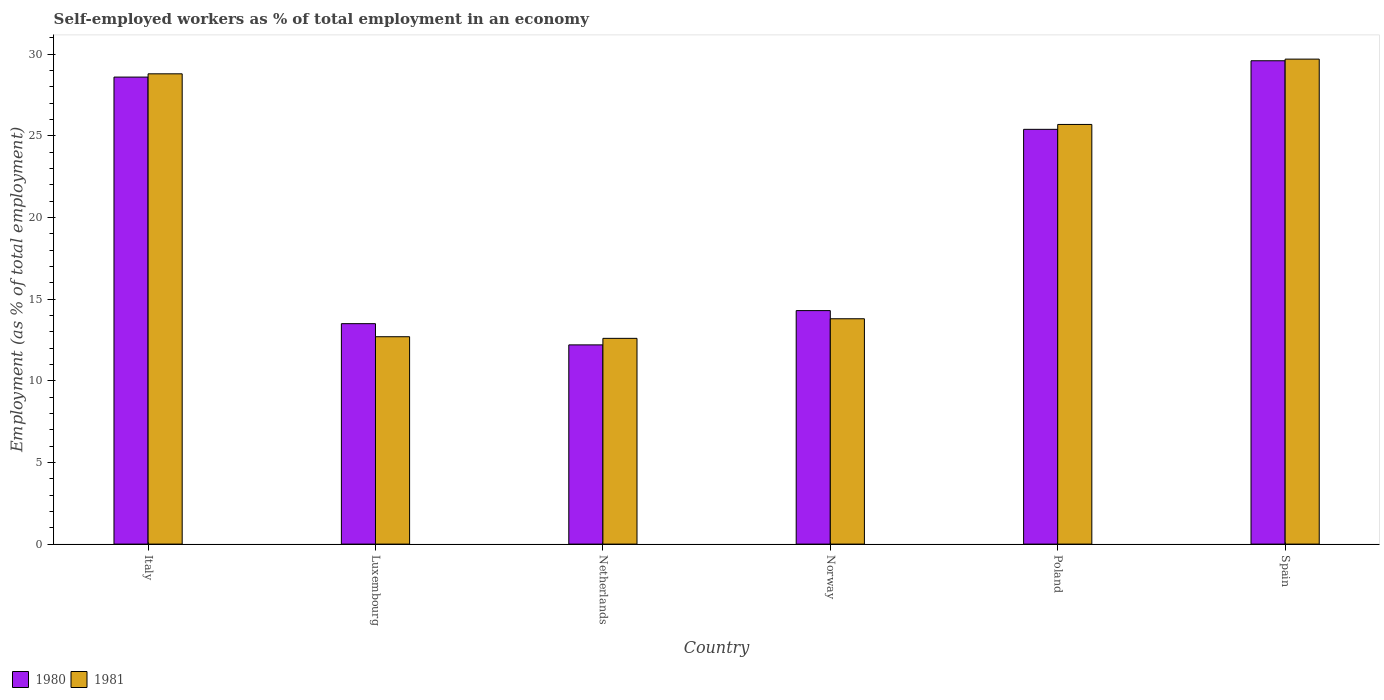How many different coloured bars are there?
Keep it short and to the point. 2. How many groups of bars are there?
Make the answer very short. 6. What is the label of the 6th group of bars from the left?
Provide a short and direct response. Spain. What is the percentage of self-employed workers in 1981 in Poland?
Keep it short and to the point. 25.7. Across all countries, what is the maximum percentage of self-employed workers in 1981?
Give a very brief answer. 29.7. Across all countries, what is the minimum percentage of self-employed workers in 1980?
Provide a succinct answer. 12.2. What is the total percentage of self-employed workers in 1981 in the graph?
Your response must be concise. 123.3. What is the difference between the percentage of self-employed workers in 1981 in Norway and that in Poland?
Provide a succinct answer. -11.9. What is the difference between the percentage of self-employed workers in 1981 in Poland and the percentage of self-employed workers in 1980 in Italy?
Give a very brief answer. -2.9. What is the average percentage of self-employed workers in 1980 per country?
Your answer should be compact. 20.6. What is the difference between the percentage of self-employed workers of/in 1980 and percentage of self-employed workers of/in 1981 in Poland?
Offer a very short reply. -0.3. What is the ratio of the percentage of self-employed workers in 1981 in Luxembourg to that in Netherlands?
Offer a very short reply. 1.01. Is the difference between the percentage of self-employed workers in 1980 in Netherlands and Norway greater than the difference between the percentage of self-employed workers in 1981 in Netherlands and Norway?
Your answer should be compact. No. What is the difference between the highest and the second highest percentage of self-employed workers in 1980?
Your answer should be very brief. -3.2. What is the difference between the highest and the lowest percentage of self-employed workers in 1980?
Give a very brief answer. 17.4. In how many countries, is the percentage of self-employed workers in 1980 greater than the average percentage of self-employed workers in 1980 taken over all countries?
Provide a short and direct response. 3. What does the 1st bar from the left in Luxembourg represents?
Provide a succinct answer. 1980. What does the 1st bar from the right in Luxembourg represents?
Provide a short and direct response. 1981. How many bars are there?
Offer a terse response. 12. How many countries are there in the graph?
Offer a terse response. 6. How many legend labels are there?
Give a very brief answer. 2. What is the title of the graph?
Offer a very short reply. Self-employed workers as % of total employment in an economy. Does "1971" appear as one of the legend labels in the graph?
Give a very brief answer. No. What is the label or title of the Y-axis?
Provide a short and direct response. Employment (as % of total employment). What is the Employment (as % of total employment) of 1980 in Italy?
Provide a succinct answer. 28.6. What is the Employment (as % of total employment) of 1981 in Italy?
Keep it short and to the point. 28.8. What is the Employment (as % of total employment) in 1981 in Luxembourg?
Offer a terse response. 12.7. What is the Employment (as % of total employment) of 1980 in Netherlands?
Ensure brevity in your answer.  12.2. What is the Employment (as % of total employment) in 1981 in Netherlands?
Give a very brief answer. 12.6. What is the Employment (as % of total employment) in 1980 in Norway?
Make the answer very short. 14.3. What is the Employment (as % of total employment) in 1981 in Norway?
Provide a succinct answer. 13.8. What is the Employment (as % of total employment) of 1980 in Poland?
Your answer should be very brief. 25.4. What is the Employment (as % of total employment) in 1981 in Poland?
Your answer should be very brief. 25.7. What is the Employment (as % of total employment) of 1980 in Spain?
Your answer should be compact. 29.6. What is the Employment (as % of total employment) of 1981 in Spain?
Keep it short and to the point. 29.7. Across all countries, what is the maximum Employment (as % of total employment) of 1980?
Your answer should be compact. 29.6. Across all countries, what is the maximum Employment (as % of total employment) in 1981?
Provide a succinct answer. 29.7. Across all countries, what is the minimum Employment (as % of total employment) in 1980?
Your answer should be very brief. 12.2. Across all countries, what is the minimum Employment (as % of total employment) in 1981?
Provide a short and direct response. 12.6. What is the total Employment (as % of total employment) of 1980 in the graph?
Ensure brevity in your answer.  123.6. What is the total Employment (as % of total employment) in 1981 in the graph?
Offer a very short reply. 123.3. What is the difference between the Employment (as % of total employment) in 1980 in Italy and that in Luxembourg?
Keep it short and to the point. 15.1. What is the difference between the Employment (as % of total employment) in 1981 in Italy and that in Luxembourg?
Provide a short and direct response. 16.1. What is the difference between the Employment (as % of total employment) in 1981 in Italy and that in Netherlands?
Offer a terse response. 16.2. What is the difference between the Employment (as % of total employment) in 1980 in Italy and that in Norway?
Give a very brief answer. 14.3. What is the difference between the Employment (as % of total employment) of 1981 in Italy and that in Norway?
Your answer should be very brief. 15. What is the difference between the Employment (as % of total employment) of 1980 in Italy and that in Poland?
Offer a terse response. 3.2. What is the difference between the Employment (as % of total employment) of 1981 in Italy and that in Spain?
Your answer should be compact. -0.9. What is the difference between the Employment (as % of total employment) of 1980 in Luxembourg and that in Netherlands?
Provide a short and direct response. 1.3. What is the difference between the Employment (as % of total employment) of 1981 in Luxembourg and that in Norway?
Give a very brief answer. -1.1. What is the difference between the Employment (as % of total employment) in 1981 in Luxembourg and that in Poland?
Give a very brief answer. -13. What is the difference between the Employment (as % of total employment) in 1980 in Luxembourg and that in Spain?
Keep it short and to the point. -16.1. What is the difference between the Employment (as % of total employment) in 1981 in Luxembourg and that in Spain?
Your response must be concise. -17. What is the difference between the Employment (as % of total employment) of 1980 in Netherlands and that in Norway?
Provide a short and direct response. -2.1. What is the difference between the Employment (as % of total employment) in 1980 in Netherlands and that in Poland?
Provide a succinct answer. -13.2. What is the difference between the Employment (as % of total employment) of 1980 in Netherlands and that in Spain?
Provide a succinct answer. -17.4. What is the difference between the Employment (as % of total employment) in 1981 in Netherlands and that in Spain?
Your response must be concise. -17.1. What is the difference between the Employment (as % of total employment) in 1980 in Norway and that in Spain?
Provide a succinct answer. -15.3. What is the difference between the Employment (as % of total employment) in 1981 in Norway and that in Spain?
Give a very brief answer. -15.9. What is the difference between the Employment (as % of total employment) of 1981 in Poland and that in Spain?
Keep it short and to the point. -4. What is the difference between the Employment (as % of total employment) in 1980 in Italy and the Employment (as % of total employment) in 1981 in Luxembourg?
Offer a very short reply. 15.9. What is the difference between the Employment (as % of total employment) in 1980 in Italy and the Employment (as % of total employment) in 1981 in Norway?
Give a very brief answer. 14.8. What is the difference between the Employment (as % of total employment) in 1980 in Italy and the Employment (as % of total employment) in 1981 in Poland?
Give a very brief answer. 2.9. What is the difference between the Employment (as % of total employment) in 1980 in Italy and the Employment (as % of total employment) in 1981 in Spain?
Provide a short and direct response. -1.1. What is the difference between the Employment (as % of total employment) in 1980 in Luxembourg and the Employment (as % of total employment) in 1981 in Norway?
Provide a short and direct response. -0.3. What is the difference between the Employment (as % of total employment) in 1980 in Luxembourg and the Employment (as % of total employment) in 1981 in Spain?
Your answer should be compact. -16.2. What is the difference between the Employment (as % of total employment) in 1980 in Netherlands and the Employment (as % of total employment) in 1981 in Spain?
Provide a short and direct response. -17.5. What is the difference between the Employment (as % of total employment) of 1980 in Norway and the Employment (as % of total employment) of 1981 in Spain?
Offer a very short reply. -15.4. What is the average Employment (as % of total employment) in 1980 per country?
Your answer should be very brief. 20.6. What is the average Employment (as % of total employment) in 1981 per country?
Provide a short and direct response. 20.55. What is the difference between the Employment (as % of total employment) of 1980 and Employment (as % of total employment) of 1981 in Italy?
Give a very brief answer. -0.2. What is the difference between the Employment (as % of total employment) of 1980 and Employment (as % of total employment) of 1981 in Netherlands?
Make the answer very short. -0.4. What is the ratio of the Employment (as % of total employment) of 1980 in Italy to that in Luxembourg?
Keep it short and to the point. 2.12. What is the ratio of the Employment (as % of total employment) of 1981 in Italy to that in Luxembourg?
Ensure brevity in your answer.  2.27. What is the ratio of the Employment (as % of total employment) in 1980 in Italy to that in Netherlands?
Keep it short and to the point. 2.34. What is the ratio of the Employment (as % of total employment) in 1981 in Italy to that in Netherlands?
Provide a short and direct response. 2.29. What is the ratio of the Employment (as % of total employment) of 1981 in Italy to that in Norway?
Your answer should be very brief. 2.09. What is the ratio of the Employment (as % of total employment) of 1980 in Italy to that in Poland?
Keep it short and to the point. 1.13. What is the ratio of the Employment (as % of total employment) in 1981 in Italy to that in Poland?
Keep it short and to the point. 1.12. What is the ratio of the Employment (as % of total employment) in 1980 in Italy to that in Spain?
Ensure brevity in your answer.  0.97. What is the ratio of the Employment (as % of total employment) of 1981 in Italy to that in Spain?
Offer a very short reply. 0.97. What is the ratio of the Employment (as % of total employment) of 1980 in Luxembourg to that in Netherlands?
Offer a terse response. 1.11. What is the ratio of the Employment (as % of total employment) in 1981 in Luxembourg to that in Netherlands?
Ensure brevity in your answer.  1.01. What is the ratio of the Employment (as % of total employment) in 1980 in Luxembourg to that in Norway?
Provide a succinct answer. 0.94. What is the ratio of the Employment (as % of total employment) in 1981 in Luxembourg to that in Norway?
Your response must be concise. 0.92. What is the ratio of the Employment (as % of total employment) in 1980 in Luxembourg to that in Poland?
Your answer should be very brief. 0.53. What is the ratio of the Employment (as % of total employment) of 1981 in Luxembourg to that in Poland?
Your response must be concise. 0.49. What is the ratio of the Employment (as % of total employment) in 1980 in Luxembourg to that in Spain?
Offer a terse response. 0.46. What is the ratio of the Employment (as % of total employment) in 1981 in Luxembourg to that in Spain?
Ensure brevity in your answer.  0.43. What is the ratio of the Employment (as % of total employment) of 1980 in Netherlands to that in Norway?
Provide a succinct answer. 0.85. What is the ratio of the Employment (as % of total employment) of 1981 in Netherlands to that in Norway?
Offer a very short reply. 0.91. What is the ratio of the Employment (as % of total employment) of 1980 in Netherlands to that in Poland?
Provide a short and direct response. 0.48. What is the ratio of the Employment (as % of total employment) in 1981 in Netherlands to that in Poland?
Keep it short and to the point. 0.49. What is the ratio of the Employment (as % of total employment) in 1980 in Netherlands to that in Spain?
Make the answer very short. 0.41. What is the ratio of the Employment (as % of total employment) in 1981 in Netherlands to that in Spain?
Provide a succinct answer. 0.42. What is the ratio of the Employment (as % of total employment) in 1980 in Norway to that in Poland?
Provide a short and direct response. 0.56. What is the ratio of the Employment (as % of total employment) in 1981 in Norway to that in Poland?
Your response must be concise. 0.54. What is the ratio of the Employment (as % of total employment) of 1980 in Norway to that in Spain?
Your answer should be very brief. 0.48. What is the ratio of the Employment (as % of total employment) of 1981 in Norway to that in Spain?
Keep it short and to the point. 0.46. What is the ratio of the Employment (as % of total employment) in 1980 in Poland to that in Spain?
Your response must be concise. 0.86. What is the ratio of the Employment (as % of total employment) in 1981 in Poland to that in Spain?
Your response must be concise. 0.87. What is the difference between the highest and the second highest Employment (as % of total employment) in 1980?
Your answer should be very brief. 1. What is the difference between the highest and the lowest Employment (as % of total employment) in 1981?
Offer a terse response. 17.1. 